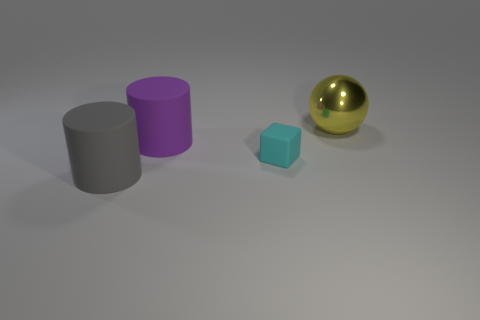There is a cyan cube that is made of the same material as the purple cylinder; what size is it?
Keep it short and to the point. Small. Is the shape of the large thing that is in front of the tiny cyan thing the same as the rubber object behind the small cyan cube?
Make the answer very short. Yes. What is the color of the big cylinder that is made of the same material as the purple object?
Keep it short and to the point. Gray. Do the thing that is in front of the cyan matte block and the yellow object that is right of the purple rubber thing have the same size?
Offer a terse response. Yes. The large thing that is both behind the cyan cube and in front of the large yellow metal object has what shape?
Give a very brief answer. Cylinder. Are there any tiny cubes that have the same material as the big gray thing?
Ensure brevity in your answer.  Yes. Is the large cylinder right of the gray thing made of the same material as the object that is on the right side of the small cyan rubber block?
Offer a terse response. No. Are there more red rubber cylinders than purple objects?
Your answer should be compact. No. What is the color of the large object behind the large rubber cylinder that is behind the large cylinder that is in front of the tiny thing?
Make the answer very short. Yellow. There is a thing that is in front of the cube; what number of big yellow metal balls are on the right side of it?
Your answer should be very brief. 1. 